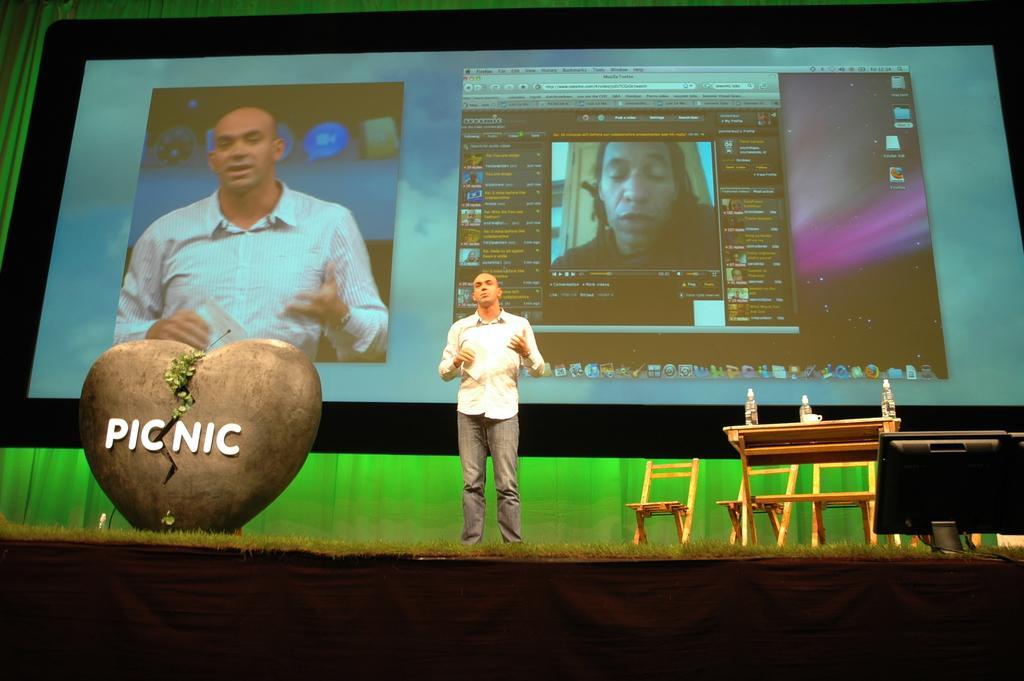Please provide a concise description of this image. This picture shows a man standing and speaking we see a table and few chairs and a screen back of him and we see a monitor. 